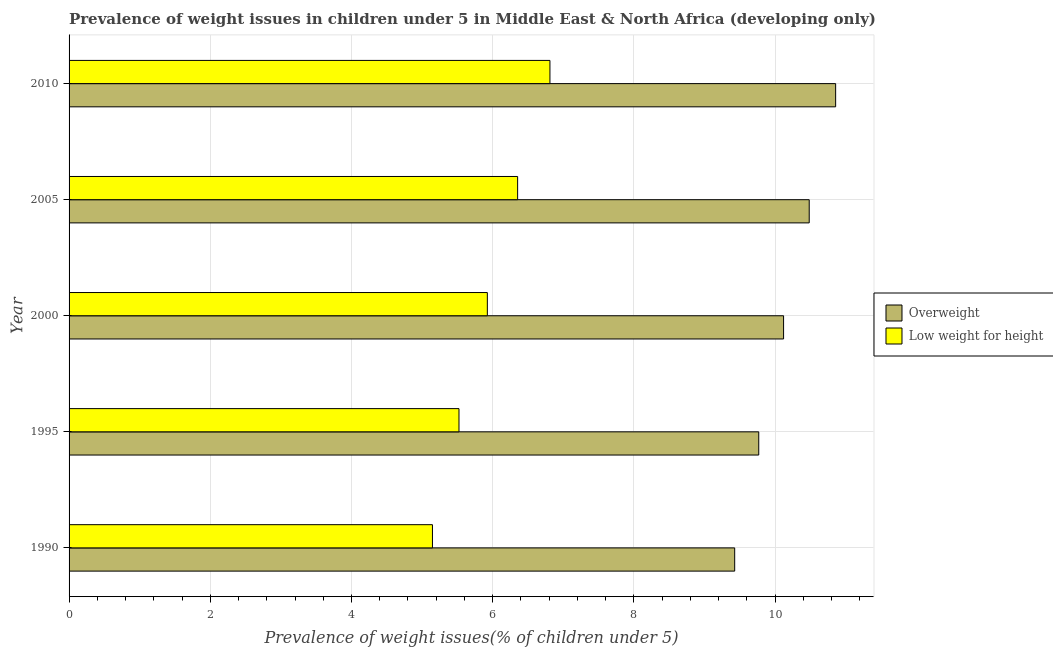Are the number of bars per tick equal to the number of legend labels?
Provide a short and direct response. Yes. Are the number of bars on each tick of the Y-axis equal?
Offer a terse response. Yes. How many bars are there on the 1st tick from the top?
Make the answer very short. 2. What is the label of the 5th group of bars from the top?
Give a very brief answer. 1990. What is the percentage of underweight children in 1990?
Make the answer very short. 5.15. Across all years, what is the maximum percentage of overweight children?
Offer a terse response. 10.86. Across all years, what is the minimum percentage of underweight children?
Offer a terse response. 5.15. In which year was the percentage of overweight children maximum?
Your answer should be very brief. 2010. In which year was the percentage of overweight children minimum?
Keep it short and to the point. 1990. What is the total percentage of underweight children in the graph?
Your response must be concise. 29.76. What is the difference between the percentage of overweight children in 1990 and that in 2000?
Provide a succinct answer. -0.69. What is the difference between the percentage of overweight children in 1995 and the percentage of underweight children in 2005?
Ensure brevity in your answer.  3.42. What is the average percentage of underweight children per year?
Ensure brevity in your answer.  5.95. In the year 1995, what is the difference between the percentage of overweight children and percentage of underweight children?
Give a very brief answer. 4.25. In how many years, is the percentage of underweight children greater than 1.6 %?
Ensure brevity in your answer.  5. What is the difference between the highest and the second highest percentage of overweight children?
Provide a short and direct response. 0.37. What is the difference between the highest and the lowest percentage of underweight children?
Keep it short and to the point. 1.66. Is the sum of the percentage of underweight children in 2005 and 2010 greater than the maximum percentage of overweight children across all years?
Provide a succinct answer. Yes. What does the 2nd bar from the top in 1990 represents?
Your answer should be compact. Overweight. What does the 1st bar from the bottom in 2005 represents?
Ensure brevity in your answer.  Overweight. Are all the bars in the graph horizontal?
Keep it short and to the point. Yes. How many years are there in the graph?
Ensure brevity in your answer.  5. What is the difference between two consecutive major ticks on the X-axis?
Ensure brevity in your answer.  2. Are the values on the major ticks of X-axis written in scientific E-notation?
Ensure brevity in your answer.  No. How are the legend labels stacked?
Offer a very short reply. Vertical. What is the title of the graph?
Provide a succinct answer. Prevalence of weight issues in children under 5 in Middle East & North Africa (developing only). Does "External balance on goods" appear as one of the legend labels in the graph?
Keep it short and to the point. No. What is the label or title of the X-axis?
Provide a succinct answer. Prevalence of weight issues(% of children under 5). What is the Prevalence of weight issues(% of children under 5) in Overweight in 1990?
Provide a succinct answer. 9.43. What is the Prevalence of weight issues(% of children under 5) of Low weight for height in 1990?
Ensure brevity in your answer.  5.15. What is the Prevalence of weight issues(% of children under 5) of Overweight in 1995?
Provide a succinct answer. 9.77. What is the Prevalence of weight issues(% of children under 5) in Low weight for height in 1995?
Your response must be concise. 5.52. What is the Prevalence of weight issues(% of children under 5) in Overweight in 2000?
Offer a very short reply. 10.12. What is the Prevalence of weight issues(% of children under 5) in Low weight for height in 2000?
Offer a terse response. 5.92. What is the Prevalence of weight issues(% of children under 5) of Overweight in 2005?
Offer a terse response. 10.48. What is the Prevalence of weight issues(% of children under 5) of Low weight for height in 2005?
Give a very brief answer. 6.35. What is the Prevalence of weight issues(% of children under 5) in Overweight in 2010?
Provide a succinct answer. 10.86. What is the Prevalence of weight issues(% of children under 5) in Low weight for height in 2010?
Ensure brevity in your answer.  6.81. Across all years, what is the maximum Prevalence of weight issues(% of children under 5) of Overweight?
Provide a succinct answer. 10.86. Across all years, what is the maximum Prevalence of weight issues(% of children under 5) in Low weight for height?
Provide a succinct answer. 6.81. Across all years, what is the minimum Prevalence of weight issues(% of children under 5) of Overweight?
Your answer should be very brief. 9.43. Across all years, what is the minimum Prevalence of weight issues(% of children under 5) of Low weight for height?
Ensure brevity in your answer.  5.15. What is the total Prevalence of weight issues(% of children under 5) in Overweight in the graph?
Give a very brief answer. 50.65. What is the total Prevalence of weight issues(% of children under 5) of Low weight for height in the graph?
Provide a succinct answer. 29.76. What is the difference between the Prevalence of weight issues(% of children under 5) of Overweight in 1990 and that in 1995?
Your answer should be very brief. -0.34. What is the difference between the Prevalence of weight issues(% of children under 5) of Low weight for height in 1990 and that in 1995?
Your response must be concise. -0.38. What is the difference between the Prevalence of weight issues(% of children under 5) in Overweight in 1990 and that in 2000?
Offer a very short reply. -0.69. What is the difference between the Prevalence of weight issues(% of children under 5) of Low weight for height in 1990 and that in 2000?
Your answer should be compact. -0.78. What is the difference between the Prevalence of weight issues(% of children under 5) in Overweight in 1990 and that in 2005?
Offer a very short reply. -1.06. What is the difference between the Prevalence of weight issues(% of children under 5) in Low weight for height in 1990 and that in 2005?
Keep it short and to the point. -1.21. What is the difference between the Prevalence of weight issues(% of children under 5) of Overweight in 1990 and that in 2010?
Make the answer very short. -1.43. What is the difference between the Prevalence of weight issues(% of children under 5) of Low weight for height in 1990 and that in 2010?
Offer a terse response. -1.66. What is the difference between the Prevalence of weight issues(% of children under 5) of Overweight in 1995 and that in 2000?
Your answer should be compact. -0.35. What is the difference between the Prevalence of weight issues(% of children under 5) in Low weight for height in 1995 and that in 2000?
Make the answer very short. -0.4. What is the difference between the Prevalence of weight issues(% of children under 5) in Overweight in 1995 and that in 2005?
Keep it short and to the point. -0.71. What is the difference between the Prevalence of weight issues(% of children under 5) of Low weight for height in 1995 and that in 2005?
Provide a succinct answer. -0.83. What is the difference between the Prevalence of weight issues(% of children under 5) of Overweight in 1995 and that in 2010?
Ensure brevity in your answer.  -1.09. What is the difference between the Prevalence of weight issues(% of children under 5) in Low weight for height in 1995 and that in 2010?
Your response must be concise. -1.29. What is the difference between the Prevalence of weight issues(% of children under 5) of Overweight in 2000 and that in 2005?
Your response must be concise. -0.36. What is the difference between the Prevalence of weight issues(% of children under 5) of Low weight for height in 2000 and that in 2005?
Make the answer very short. -0.43. What is the difference between the Prevalence of weight issues(% of children under 5) of Overweight in 2000 and that in 2010?
Ensure brevity in your answer.  -0.74. What is the difference between the Prevalence of weight issues(% of children under 5) of Low weight for height in 2000 and that in 2010?
Provide a short and direct response. -0.89. What is the difference between the Prevalence of weight issues(% of children under 5) in Overweight in 2005 and that in 2010?
Your answer should be very brief. -0.37. What is the difference between the Prevalence of weight issues(% of children under 5) of Low weight for height in 2005 and that in 2010?
Ensure brevity in your answer.  -0.46. What is the difference between the Prevalence of weight issues(% of children under 5) in Overweight in 1990 and the Prevalence of weight issues(% of children under 5) in Low weight for height in 1995?
Give a very brief answer. 3.9. What is the difference between the Prevalence of weight issues(% of children under 5) in Overweight in 1990 and the Prevalence of weight issues(% of children under 5) in Low weight for height in 2000?
Offer a terse response. 3.5. What is the difference between the Prevalence of weight issues(% of children under 5) in Overweight in 1990 and the Prevalence of weight issues(% of children under 5) in Low weight for height in 2005?
Keep it short and to the point. 3.07. What is the difference between the Prevalence of weight issues(% of children under 5) in Overweight in 1990 and the Prevalence of weight issues(% of children under 5) in Low weight for height in 2010?
Your answer should be compact. 2.62. What is the difference between the Prevalence of weight issues(% of children under 5) in Overweight in 1995 and the Prevalence of weight issues(% of children under 5) in Low weight for height in 2000?
Your response must be concise. 3.84. What is the difference between the Prevalence of weight issues(% of children under 5) of Overweight in 1995 and the Prevalence of weight issues(% of children under 5) of Low weight for height in 2005?
Your answer should be compact. 3.42. What is the difference between the Prevalence of weight issues(% of children under 5) in Overweight in 1995 and the Prevalence of weight issues(% of children under 5) in Low weight for height in 2010?
Make the answer very short. 2.96. What is the difference between the Prevalence of weight issues(% of children under 5) of Overweight in 2000 and the Prevalence of weight issues(% of children under 5) of Low weight for height in 2005?
Your answer should be compact. 3.77. What is the difference between the Prevalence of weight issues(% of children under 5) of Overweight in 2000 and the Prevalence of weight issues(% of children under 5) of Low weight for height in 2010?
Your response must be concise. 3.31. What is the difference between the Prevalence of weight issues(% of children under 5) of Overweight in 2005 and the Prevalence of weight issues(% of children under 5) of Low weight for height in 2010?
Provide a succinct answer. 3.67. What is the average Prevalence of weight issues(% of children under 5) in Overweight per year?
Your answer should be compact. 10.13. What is the average Prevalence of weight issues(% of children under 5) in Low weight for height per year?
Provide a short and direct response. 5.95. In the year 1990, what is the difference between the Prevalence of weight issues(% of children under 5) in Overweight and Prevalence of weight issues(% of children under 5) in Low weight for height?
Make the answer very short. 4.28. In the year 1995, what is the difference between the Prevalence of weight issues(% of children under 5) in Overweight and Prevalence of weight issues(% of children under 5) in Low weight for height?
Give a very brief answer. 4.25. In the year 2000, what is the difference between the Prevalence of weight issues(% of children under 5) of Overweight and Prevalence of weight issues(% of children under 5) of Low weight for height?
Offer a very short reply. 4.2. In the year 2005, what is the difference between the Prevalence of weight issues(% of children under 5) in Overweight and Prevalence of weight issues(% of children under 5) in Low weight for height?
Provide a short and direct response. 4.13. In the year 2010, what is the difference between the Prevalence of weight issues(% of children under 5) of Overweight and Prevalence of weight issues(% of children under 5) of Low weight for height?
Ensure brevity in your answer.  4.05. What is the ratio of the Prevalence of weight issues(% of children under 5) of Overweight in 1990 to that in 1995?
Your answer should be compact. 0.97. What is the ratio of the Prevalence of weight issues(% of children under 5) in Low weight for height in 1990 to that in 1995?
Ensure brevity in your answer.  0.93. What is the ratio of the Prevalence of weight issues(% of children under 5) in Overweight in 1990 to that in 2000?
Provide a short and direct response. 0.93. What is the ratio of the Prevalence of weight issues(% of children under 5) in Low weight for height in 1990 to that in 2000?
Offer a terse response. 0.87. What is the ratio of the Prevalence of weight issues(% of children under 5) in Overweight in 1990 to that in 2005?
Make the answer very short. 0.9. What is the ratio of the Prevalence of weight issues(% of children under 5) in Low weight for height in 1990 to that in 2005?
Your answer should be very brief. 0.81. What is the ratio of the Prevalence of weight issues(% of children under 5) of Overweight in 1990 to that in 2010?
Provide a short and direct response. 0.87. What is the ratio of the Prevalence of weight issues(% of children under 5) of Low weight for height in 1990 to that in 2010?
Offer a very short reply. 0.76. What is the ratio of the Prevalence of weight issues(% of children under 5) in Overweight in 1995 to that in 2000?
Your answer should be very brief. 0.97. What is the ratio of the Prevalence of weight issues(% of children under 5) in Low weight for height in 1995 to that in 2000?
Offer a terse response. 0.93. What is the ratio of the Prevalence of weight issues(% of children under 5) in Overweight in 1995 to that in 2005?
Your response must be concise. 0.93. What is the ratio of the Prevalence of weight issues(% of children under 5) of Low weight for height in 1995 to that in 2005?
Make the answer very short. 0.87. What is the ratio of the Prevalence of weight issues(% of children under 5) of Overweight in 1995 to that in 2010?
Your response must be concise. 0.9. What is the ratio of the Prevalence of weight issues(% of children under 5) of Low weight for height in 1995 to that in 2010?
Your response must be concise. 0.81. What is the ratio of the Prevalence of weight issues(% of children under 5) of Overweight in 2000 to that in 2005?
Give a very brief answer. 0.97. What is the ratio of the Prevalence of weight issues(% of children under 5) in Low weight for height in 2000 to that in 2005?
Your answer should be compact. 0.93. What is the ratio of the Prevalence of weight issues(% of children under 5) in Overweight in 2000 to that in 2010?
Keep it short and to the point. 0.93. What is the ratio of the Prevalence of weight issues(% of children under 5) of Low weight for height in 2000 to that in 2010?
Your answer should be compact. 0.87. What is the ratio of the Prevalence of weight issues(% of children under 5) in Overweight in 2005 to that in 2010?
Make the answer very short. 0.97. What is the ratio of the Prevalence of weight issues(% of children under 5) in Low weight for height in 2005 to that in 2010?
Give a very brief answer. 0.93. What is the difference between the highest and the second highest Prevalence of weight issues(% of children under 5) in Overweight?
Keep it short and to the point. 0.37. What is the difference between the highest and the second highest Prevalence of weight issues(% of children under 5) of Low weight for height?
Your answer should be very brief. 0.46. What is the difference between the highest and the lowest Prevalence of weight issues(% of children under 5) of Overweight?
Offer a terse response. 1.43. What is the difference between the highest and the lowest Prevalence of weight issues(% of children under 5) of Low weight for height?
Give a very brief answer. 1.66. 